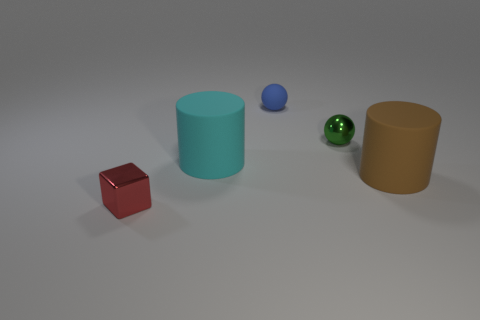Add 2 green things. How many objects exist? 7 Subtract all cylinders. How many objects are left? 3 Add 5 balls. How many balls are left? 7 Add 2 small matte blocks. How many small matte blocks exist? 2 Subtract 0 green cubes. How many objects are left? 5 Subtract all blue rubber things. Subtract all small metal blocks. How many objects are left? 3 